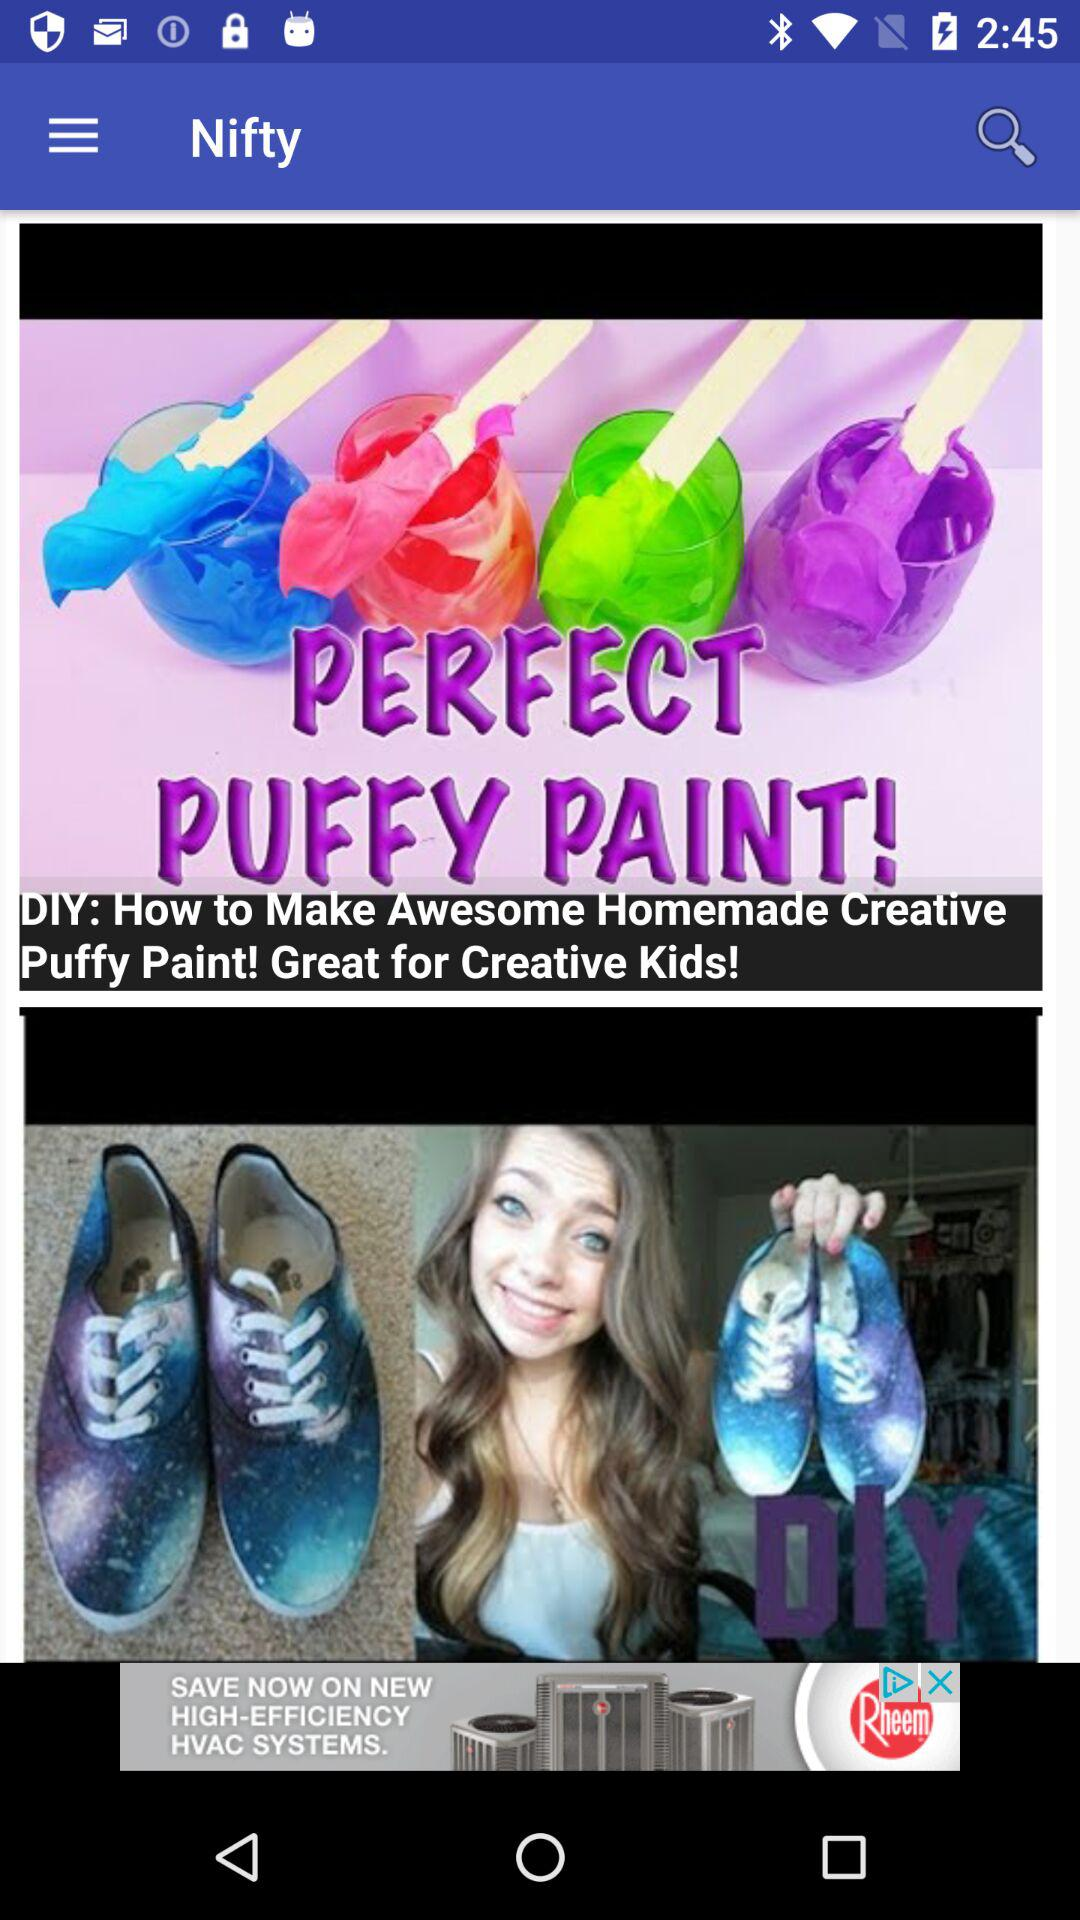What is the name of the application? The application name is "Nifty". 